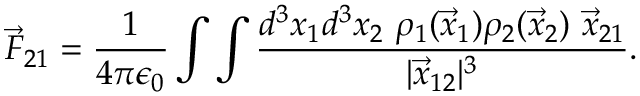Convert formula to latex. <formula><loc_0><loc_0><loc_500><loc_500>\vec { F } _ { 2 1 } = \frac { 1 } { 4 \pi \epsilon _ { 0 } } \int \int \frac { d ^ { 3 } x _ { 1 } d ^ { 3 } x _ { 2 } \ \rho _ { 1 } ( \vec { x } _ { 1 } ) \rho _ { 2 } ( \vec { x } _ { 2 } ) \ \vec { x } _ { 2 1 } } { | \vec { x } _ { 1 2 } | ^ { 3 } } .</formula> 